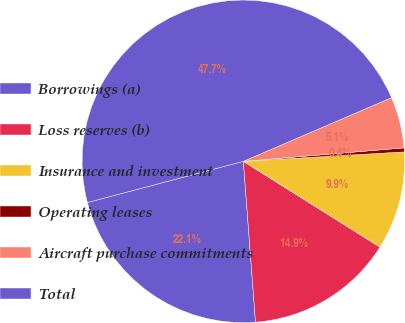Convert chart. <chart><loc_0><loc_0><loc_500><loc_500><pie_chart><fcel>Borrowings (a)<fcel>Loss reserves (b)<fcel>Insurance and investment<fcel>Operating leases<fcel>Aircraft purchase commitments<fcel>Total<nl><fcel>22.09%<fcel>14.88%<fcel>9.85%<fcel>0.4%<fcel>5.13%<fcel>47.65%<nl></chart> 